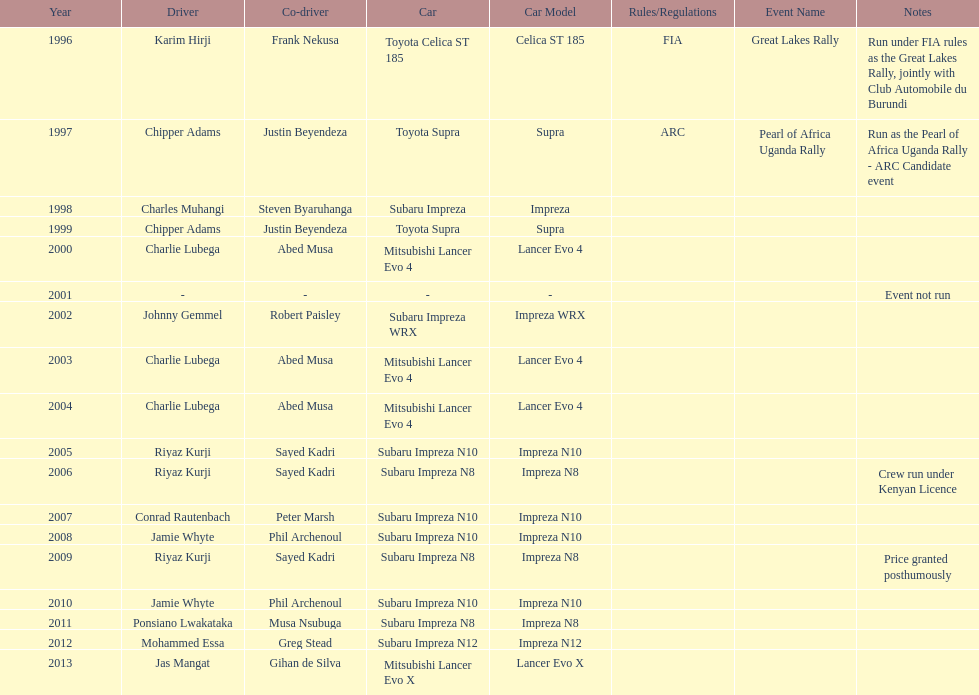Which was the only year that the event was not run? 2001. 